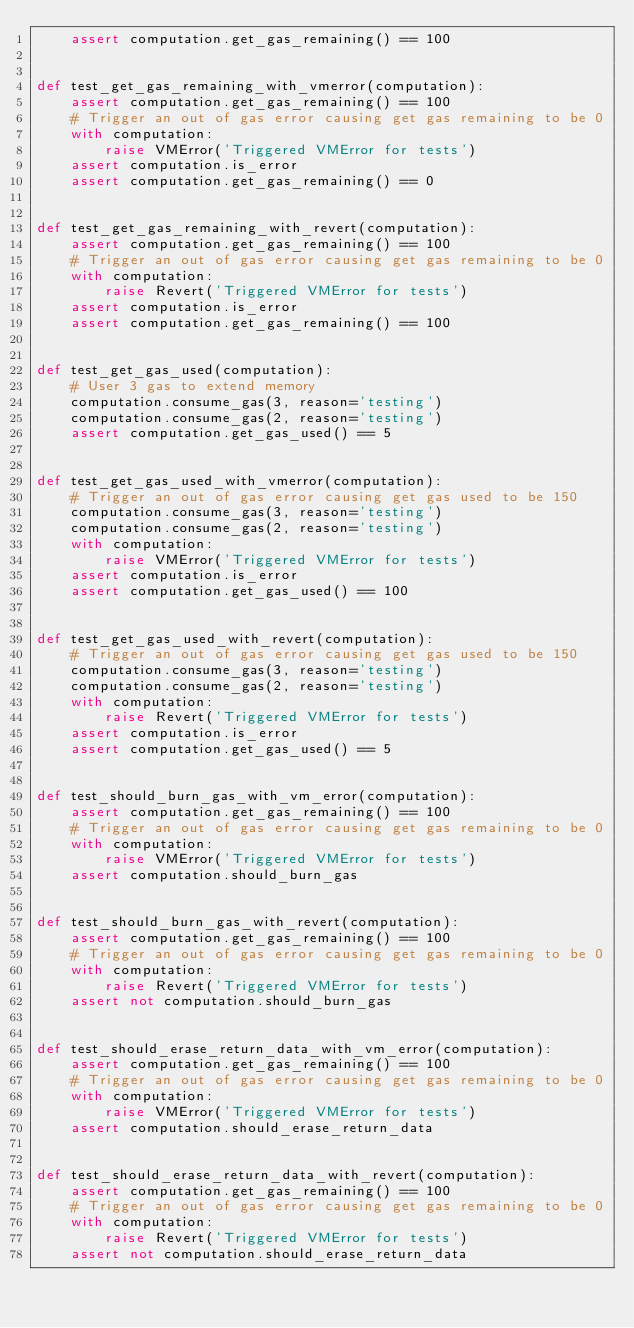Convert code to text. <code><loc_0><loc_0><loc_500><loc_500><_Python_>    assert computation.get_gas_remaining() == 100


def test_get_gas_remaining_with_vmerror(computation):
    assert computation.get_gas_remaining() == 100
    # Trigger an out of gas error causing get gas remaining to be 0
    with computation:
        raise VMError('Triggered VMError for tests')
    assert computation.is_error
    assert computation.get_gas_remaining() == 0


def test_get_gas_remaining_with_revert(computation):
    assert computation.get_gas_remaining() == 100
    # Trigger an out of gas error causing get gas remaining to be 0
    with computation:
        raise Revert('Triggered VMError for tests')
    assert computation.is_error
    assert computation.get_gas_remaining() == 100


def test_get_gas_used(computation):
    # User 3 gas to extend memory
    computation.consume_gas(3, reason='testing')
    computation.consume_gas(2, reason='testing')
    assert computation.get_gas_used() == 5


def test_get_gas_used_with_vmerror(computation):
    # Trigger an out of gas error causing get gas used to be 150
    computation.consume_gas(3, reason='testing')
    computation.consume_gas(2, reason='testing')
    with computation:
        raise VMError('Triggered VMError for tests')
    assert computation.is_error
    assert computation.get_gas_used() == 100


def test_get_gas_used_with_revert(computation):
    # Trigger an out of gas error causing get gas used to be 150
    computation.consume_gas(3, reason='testing')
    computation.consume_gas(2, reason='testing')
    with computation:
        raise Revert('Triggered VMError for tests')
    assert computation.is_error
    assert computation.get_gas_used() == 5


def test_should_burn_gas_with_vm_error(computation):
    assert computation.get_gas_remaining() == 100
    # Trigger an out of gas error causing get gas remaining to be 0
    with computation:
        raise VMError('Triggered VMError for tests')
    assert computation.should_burn_gas


def test_should_burn_gas_with_revert(computation):
    assert computation.get_gas_remaining() == 100
    # Trigger an out of gas error causing get gas remaining to be 0
    with computation:
        raise Revert('Triggered VMError for tests')
    assert not computation.should_burn_gas


def test_should_erase_return_data_with_vm_error(computation):
    assert computation.get_gas_remaining() == 100
    # Trigger an out of gas error causing get gas remaining to be 0
    with computation:
        raise VMError('Triggered VMError for tests')
    assert computation.should_erase_return_data


def test_should_erase_return_data_with_revert(computation):
    assert computation.get_gas_remaining() == 100
    # Trigger an out of gas error causing get gas remaining to be 0
    with computation:
        raise Revert('Triggered VMError for tests')
    assert not computation.should_erase_return_data
</code> 